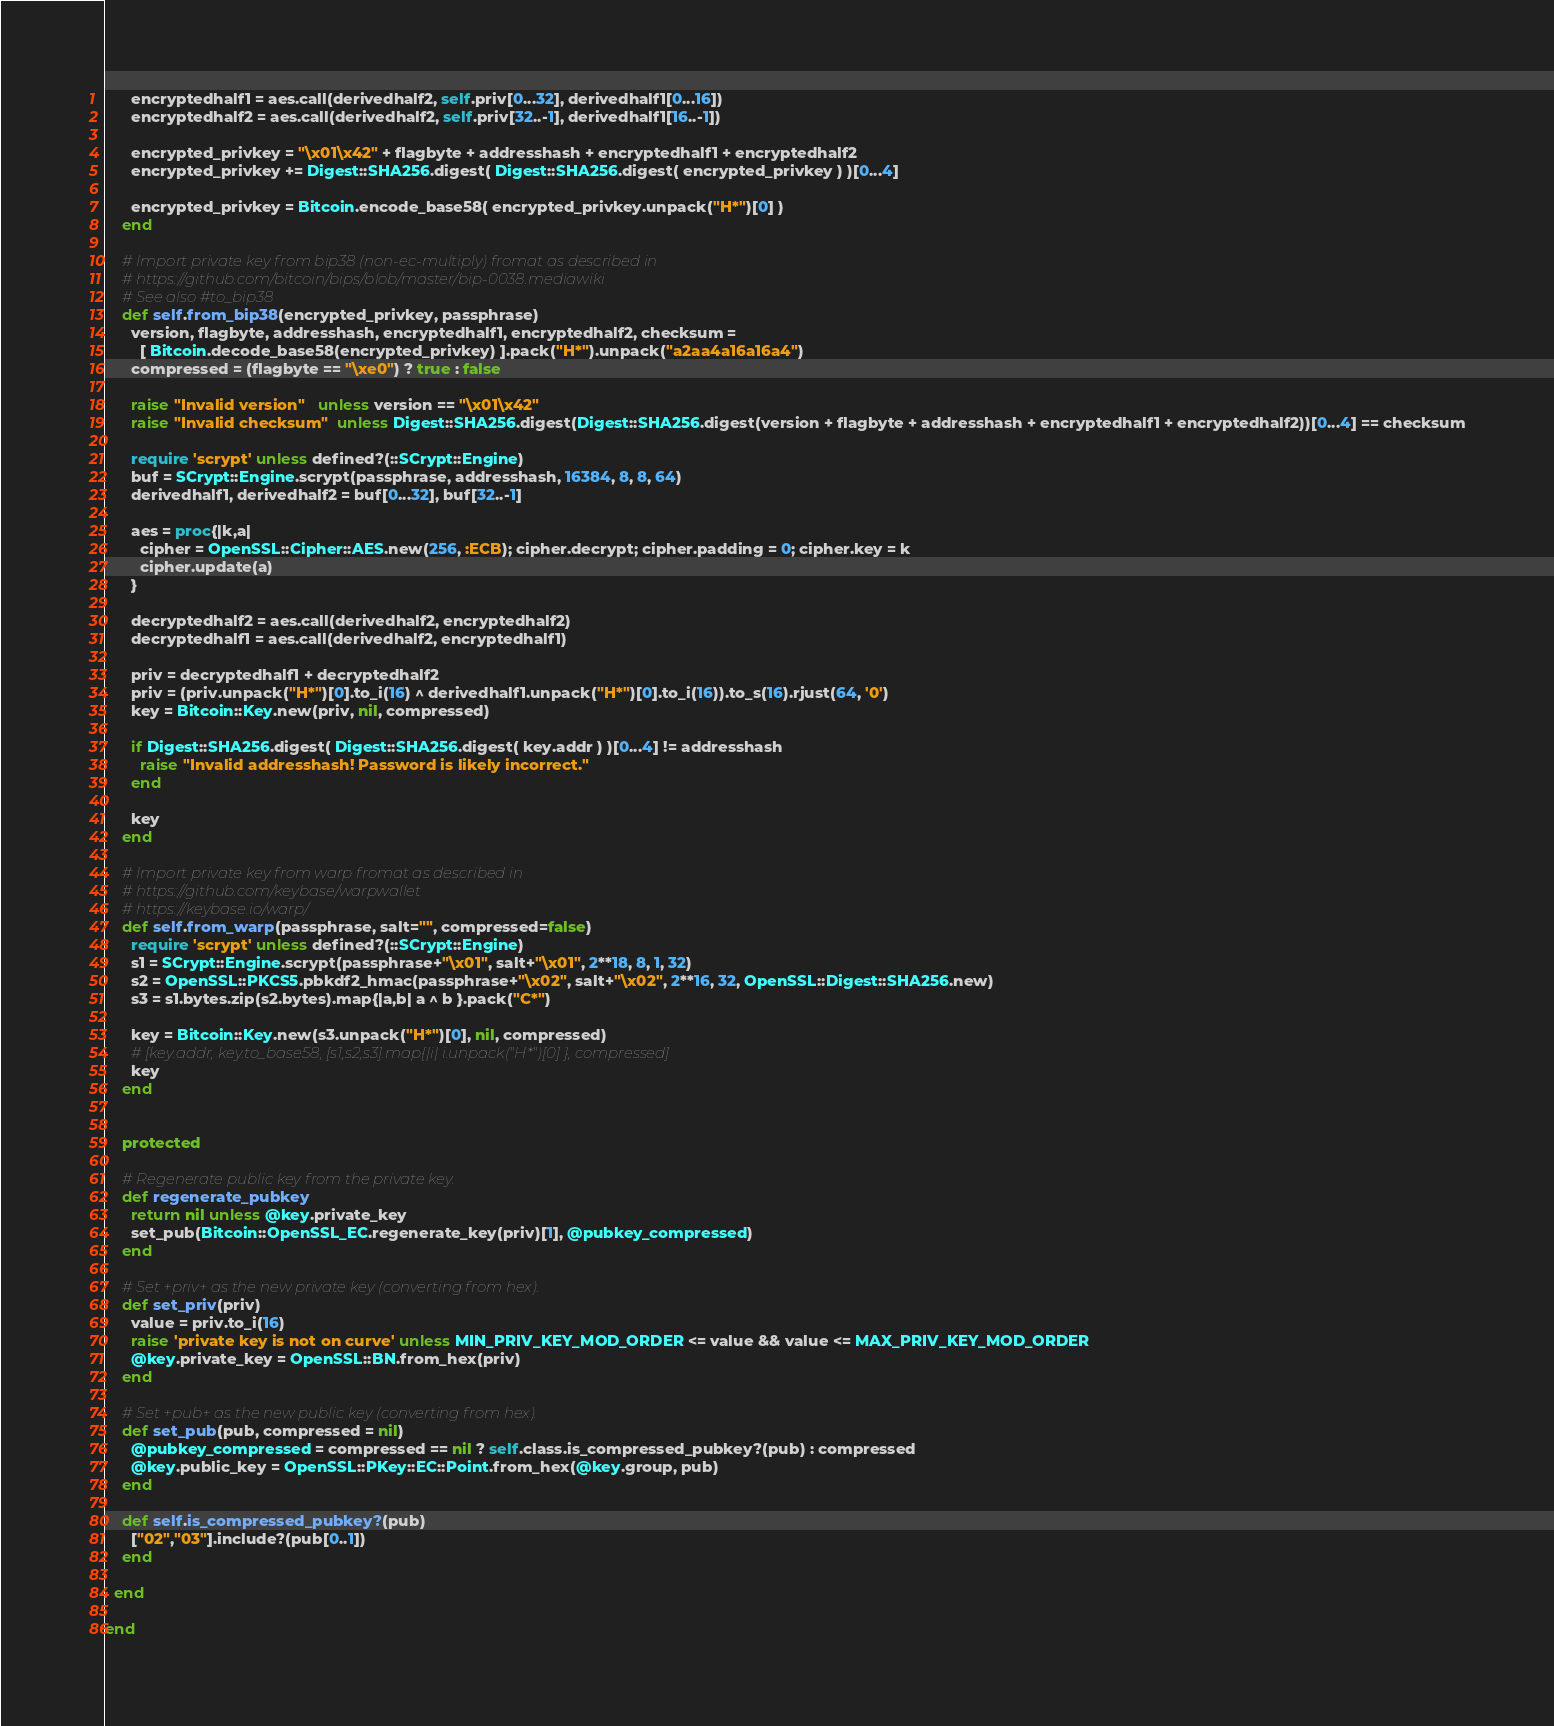Convert code to text. <code><loc_0><loc_0><loc_500><loc_500><_Ruby_>      encryptedhalf1 = aes.call(derivedhalf2, self.priv[0...32], derivedhalf1[0...16])
      encryptedhalf2 = aes.call(derivedhalf2, self.priv[32..-1], derivedhalf1[16..-1])

      encrypted_privkey = "\x01\x42" + flagbyte + addresshash + encryptedhalf1 + encryptedhalf2
      encrypted_privkey += Digest::SHA256.digest( Digest::SHA256.digest( encrypted_privkey ) )[0...4]

      encrypted_privkey = Bitcoin.encode_base58( encrypted_privkey.unpack("H*")[0] )
    end

    # Import private key from bip38 (non-ec-multiply) fromat as described in
    # https://github.com/bitcoin/bips/blob/master/bip-0038.mediawiki
    # See also #to_bip38
    def self.from_bip38(encrypted_privkey, passphrase)
      version, flagbyte, addresshash, encryptedhalf1, encryptedhalf2, checksum =
        [ Bitcoin.decode_base58(encrypted_privkey) ].pack("H*").unpack("a2aa4a16a16a4")
      compressed = (flagbyte == "\xe0") ? true : false

      raise "Invalid version"   unless version == "\x01\x42"
      raise "Invalid checksum"  unless Digest::SHA256.digest(Digest::SHA256.digest(version + flagbyte + addresshash + encryptedhalf1 + encryptedhalf2))[0...4] == checksum

      require 'scrypt' unless defined?(::SCrypt::Engine)
      buf = SCrypt::Engine.scrypt(passphrase, addresshash, 16384, 8, 8, 64)
      derivedhalf1, derivedhalf2 = buf[0...32], buf[32..-1]

      aes = proc{|k,a|
        cipher = OpenSSL::Cipher::AES.new(256, :ECB); cipher.decrypt; cipher.padding = 0; cipher.key = k
        cipher.update(a)
      }

      decryptedhalf2 = aes.call(derivedhalf2, encryptedhalf2)
      decryptedhalf1 = aes.call(derivedhalf2, encryptedhalf1)

      priv = decryptedhalf1 + decryptedhalf2
      priv = (priv.unpack("H*")[0].to_i(16) ^ derivedhalf1.unpack("H*")[0].to_i(16)).to_s(16).rjust(64, '0')
      key = Bitcoin::Key.new(priv, nil, compressed)

      if Digest::SHA256.digest( Digest::SHA256.digest( key.addr ) )[0...4] != addresshash
        raise "Invalid addresshash! Password is likely incorrect."
      end

      key
    end

    # Import private key from warp fromat as described in
    # https://github.com/keybase/warpwallet
    # https://keybase.io/warp/
    def self.from_warp(passphrase, salt="", compressed=false)
      require 'scrypt' unless defined?(::SCrypt::Engine)
      s1 = SCrypt::Engine.scrypt(passphrase+"\x01", salt+"\x01", 2**18, 8, 1, 32)
      s2 = OpenSSL::PKCS5.pbkdf2_hmac(passphrase+"\x02", salt+"\x02", 2**16, 32, OpenSSL::Digest::SHA256.new)
      s3 = s1.bytes.zip(s2.bytes).map{|a,b| a ^ b }.pack("C*")

      key = Bitcoin::Key.new(s3.unpack("H*")[0], nil, compressed)
      # [key.addr, key.to_base58, [s1,s2,s3].map{|i| i.unpack("H*")[0] }, compressed]
      key
    end


    protected

    # Regenerate public key from the private key.
    def regenerate_pubkey
      return nil unless @key.private_key
      set_pub(Bitcoin::OpenSSL_EC.regenerate_key(priv)[1], @pubkey_compressed)
    end

    # Set +priv+ as the new private key (converting from hex).
    def set_priv(priv)
      value = priv.to_i(16)
      raise 'private key is not on curve' unless MIN_PRIV_KEY_MOD_ORDER <= value && value <= MAX_PRIV_KEY_MOD_ORDER
      @key.private_key = OpenSSL::BN.from_hex(priv)
    end

    # Set +pub+ as the new public key (converting from hex).
    def set_pub(pub, compressed = nil)
      @pubkey_compressed = compressed == nil ? self.class.is_compressed_pubkey?(pub) : compressed
      @key.public_key = OpenSSL::PKey::EC::Point.from_hex(@key.group, pub)
    end

    def self.is_compressed_pubkey?(pub)
      ["02","03"].include?(pub[0..1])
    end

  end

end

</code> 